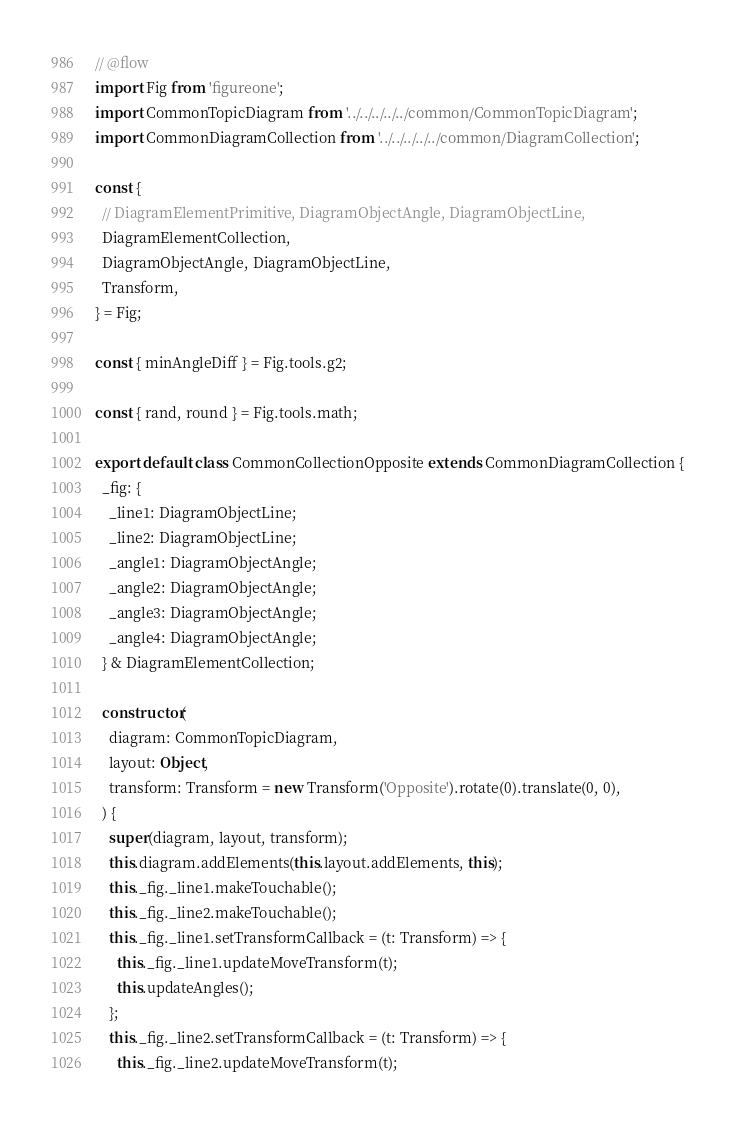Convert code to text. <code><loc_0><loc_0><loc_500><loc_500><_JavaScript_>// @flow
import Fig from 'figureone';
import CommonTopicDiagram from '../../../../../common/CommonTopicDiagram';
import CommonDiagramCollection from '../../../../../common/DiagramCollection';

const {
  // DiagramElementPrimitive, DiagramObjectAngle, DiagramObjectLine,
  DiagramElementCollection,
  DiagramObjectAngle, DiagramObjectLine,
  Transform,
} = Fig;

const { minAngleDiff } = Fig.tools.g2;

const { rand, round } = Fig.tools.math;

export default class CommonCollectionOpposite extends CommonDiagramCollection {
  _fig: {
    _line1: DiagramObjectLine;
    _line2: DiagramObjectLine;
    _angle1: DiagramObjectAngle;
    _angle2: DiagramObjectAngle;
    _angle3: DiagramObjectAngle;
    _angle4: DiagramObjectAngle;
  } & DiagramElementCollection;

  constructor(
    diagram: CommonTopicDiagram,
    layout: Object,
    transform: Transform = new Transform('Opposite').rotate(0).translate(0, 0),
  ) {
    super(diagram, layout, transform);
    this.diagram.addElements(this.layout.addElements, this);
    this._fig._line1.makeTouchable();
    this._fig._line2.makeTouchable();
    this._fig._line1.setTransformCallback = (t: Transform) => {
      this._fig._line1.updateMoveTransform(t);
      this.updateAngles();
    };
    this._fig._line2.setTransformCallback = (t: Transform) => {
      this._fig._line2.updateMoveTransform(t);</code> 